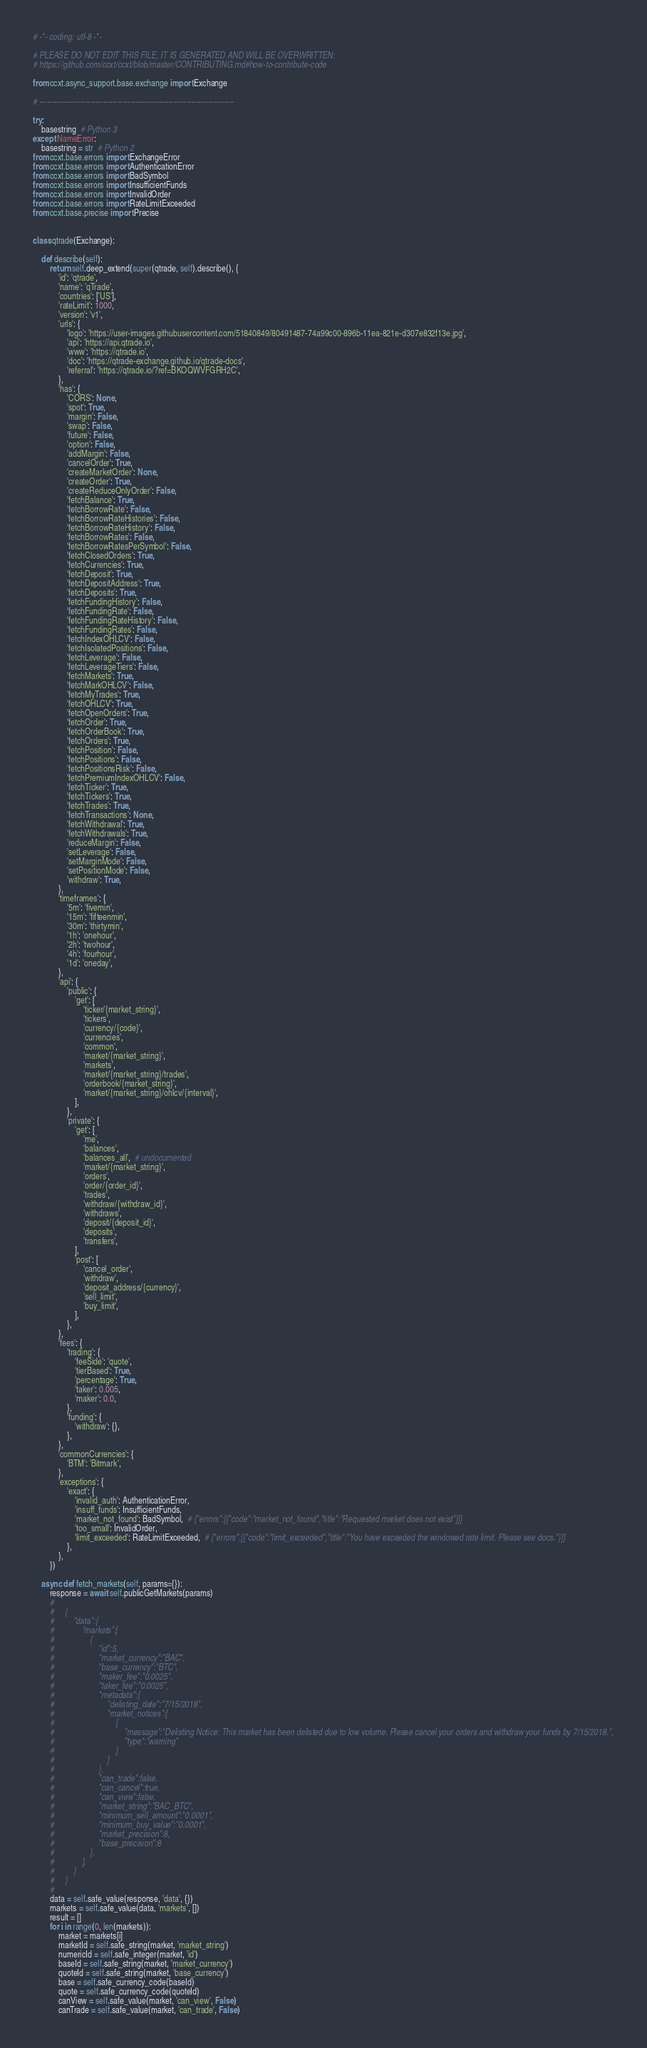<code> <loc_0><loc_0><loc_500><loc_500><_Python_># -*- coding: utf-8 -*-

# PLEASE DO NOT EDIT THIS FILE, IT IS GENERATED AND WILL BE OVERWRITTEN:
# https://github.com/ccxt/ccxt/blob/master/CONTRIBUTING.md#how-to-contribute-code

from ccxt.async_support.base.exchange import Exchange

# -----------------------------------------------------------------------------

try:
    basestring  # Python 3
except NameError:
    basestring = str  # Python 2
from ccxt.base.errors import ExchangeError
from ccxt.base.errors import AuthenticationError
from ccxt.base.errors import BadSymbol
from ccxt.base.errors import InsufficientFunds
from ccxt.base.errors import InvalidOrder
from ccxt.base.errors import RateLimitExceeded
from ccxt.base.precise import Precise


class qtrade(Exchange):

    def describe(self):
        return self.deep_extend(super(qtrade, self).describe(), {
            'id': 'qtrade',
            'name': 'qTrade',
            'countries': ['US'],
            'rateLimit': 1000,
            'version': 'v1',
            'urls': {
                'logo': 'https://user-images.githubusercontent.com/51840849/80491487-74a99c00-896b-11ea-821e-d307e832f13e.jpg',
                'api': 'https://api.qtrade.io',
                'www': 'https://qtrade.io',
                'doc': 'https://qtrade-exchange.github.io/qtrade-docs',
                'referral': 'https://qtrade.io/?ref=BKOQWVFGRH2C',
            },
            'has': {
                'CORS': None,
                'spot': True,
                'margin': False,
                'swap': False,
                'future': False,
                'option': False,
                'addMargin': False,
                'cancelOrder': True,
                'createMarketOrder': None,
                'createOrder': True,
                'createReduceOnlyOrder': False,
                'fetchBalance': True,
                'fetchBorrowRate': False,
                'fetchBorrowRateHistories': False,
                'fetchBorrowRateHistory': False,
                'fetchBorrowRates': False,
                'fetchBorrowRatesPerSymbol': False,
                'fetchClosedOrders': True,
                'fetchCurrencies': True,
                'fetchDeposit': True,
                'fetchDepositAddress': True,
                'fetchDeposits': True,
                'fetchFundingHistory': False,
                'fetchFundingRate': False,
                'fetchFundingRateHistory': False,
                'fetchFundingRates': False,
                'fetchIndexOHLCV': False,
                'fetchIsolatedPositions': False,
                'fetchLeverage': False,
                'fetchLeverageTiers': False,
                'fetchMarkets': True,
                'fetchMarkOHLCV': False,
                'fetchMyTrades': True,
                'fetchOHLCV': True,
                'fetchOpenOrders': True,
                'fetchOrder': True,
                'fetchOrderBook': True,
                'fetchOrders': True,
                'fetchPosition': False,
                'fetchPositions': False,
                'fetchPositionsRisk': False,
                'fetchPremiumIndexOHLCV': False,
                'fetchTicker': True,
                'fetchTickers': True,
                'fetchTrades': True,
                'fetchTransactions': None,
                'fetchWithdrawal': True,
                'fetchWithdrawals': True,
                'reduceMargin': False,
                'setLeverage': False,
                'setMarginMode': False,
                'setPositionMode': False,
                'withdraw': True,
            },
            'timeframes': {
                '5m': 'fivemin',
                '15m': 'fifteenmin',
                '30m': 'thirtymin',
                '1h': 'onehour',
                '2h': 'twohour',
                '4h': 'fourhour',
                '1d': 'oneday',
            },
            'api': {
                'public': {
                    'get': [
                        'ticker/{market_string}',
                        'tickers',
                        'currency/{code}',
                        'currencies',
                        'common',
                        'market/{market_string}',
                        'markets',
                        'market/{market_string}/trades',
                        'orderbook/{market_string}',
                        'market/{market_string}/ohlcv/{interval}',
                    ],
                },
                'private': {
                    'get': [
                        'me',
                        'balances',
                        'balances_all',  # undocumented
                        'market/{market_string}',
                        'orders',
                        'order/{order_id}',
                        'trades',
                        'withdraw/{withdraw_id}',
                        'withdraws',
                        'deposit/{deposit_id}',
                        'deposits',
                        'transfers',
                    ],
                    'post': [
                        'cancel_order',
                        'withdraw',
                        'deposit_address/{currency}',
                        'sell_limit',
                        'buy_limit',
                    ],
                },
            },
            'fees': {
                'trading': {
                    'feeSide': 'quote',
                    'tierBased': True,
                    'percentage': True,
                    'taker': 0.005,
                    'maker': 0.0,
                },
                'funding': {
                    'withdraw': {},
                },
            },
            'commonCurrencies': {
                'BTM': 'Bitmark',
            },
            'exceptions': {
                'exact': {
                    'invalid_auth': AuthenticationError,
                    'insuff_funds': InsufficientFunds,
                    'market_not_found': BadSymbol,  # {"errors":[{"code":"market_not_found","title":"Requested market does not exist"}]}
                    'too_small': InvalidOrder,
                    'limit_exceeded': RateLimitExceeded,  # {"errors":[{"code":"limit_exceeded","title":"You have exceeded the windowed rate limit. Please see docs."}]}
                },
            },
        })

    async def fetch_markets(self, params={}):
        response = await self.publicGetMarkets(params)
        #
        #     {
        #         "data":{
        #             "markets":[
        #                 {
        #                     "id":5,
        #                     "market_currency":"BAC",
        #                     "base_currency":"BTC",
        #                     "maker_fee":"0.0025",
        #                     "taker_fee":"0.0025",
        #                     "metadata":{
        #                         "delisting_date":"7/15/2018",
        #                         "market_notices":[
        #                             {
        #                                 "message":"Delisting Notice: This market has been delisted due to low volume. Please cancel your orders and withdraw your funds by 7/15/2018.",
        #                                 "type":"warning"
        #                             }
        #                         ]
        #                     },
        #                     "can_trade":false,
        #                     "can_cancel":true,
        #                     "can_view":false,
        #                     "market_string":"BAC_BTC",
        #                     "minimum_sell_amount":"0.0001",
        #                     "minimum_buy_value":"0.0001",
        #                     "market_precision":8,
        #                     "base_precision":8
        #                 },
        #             ],
        #         }
        #     }
        #
        data = self.safe_value(response, 'data', {})
        markets = self.safe_value(data, 'markets', [])
        result = []
        for i in range(0, len(markets)):
            market = markets[i]
            marketId = self.safe_string(market, 'market_string')
            numericId = self.safe_integer(market, 'id')
            baseId = self.safe_string(market, 'market_currency')
            quoteId = self.safe_string(market, 'base_currency')
            base = self.safe_currency_code(baseId)
            quote = self.safe_currency_code(quoteId)
            canView = self.safe_value(market, 'can_view', False)
            canTrade = self.safe_value(market, 'can_trade', False)</code> 